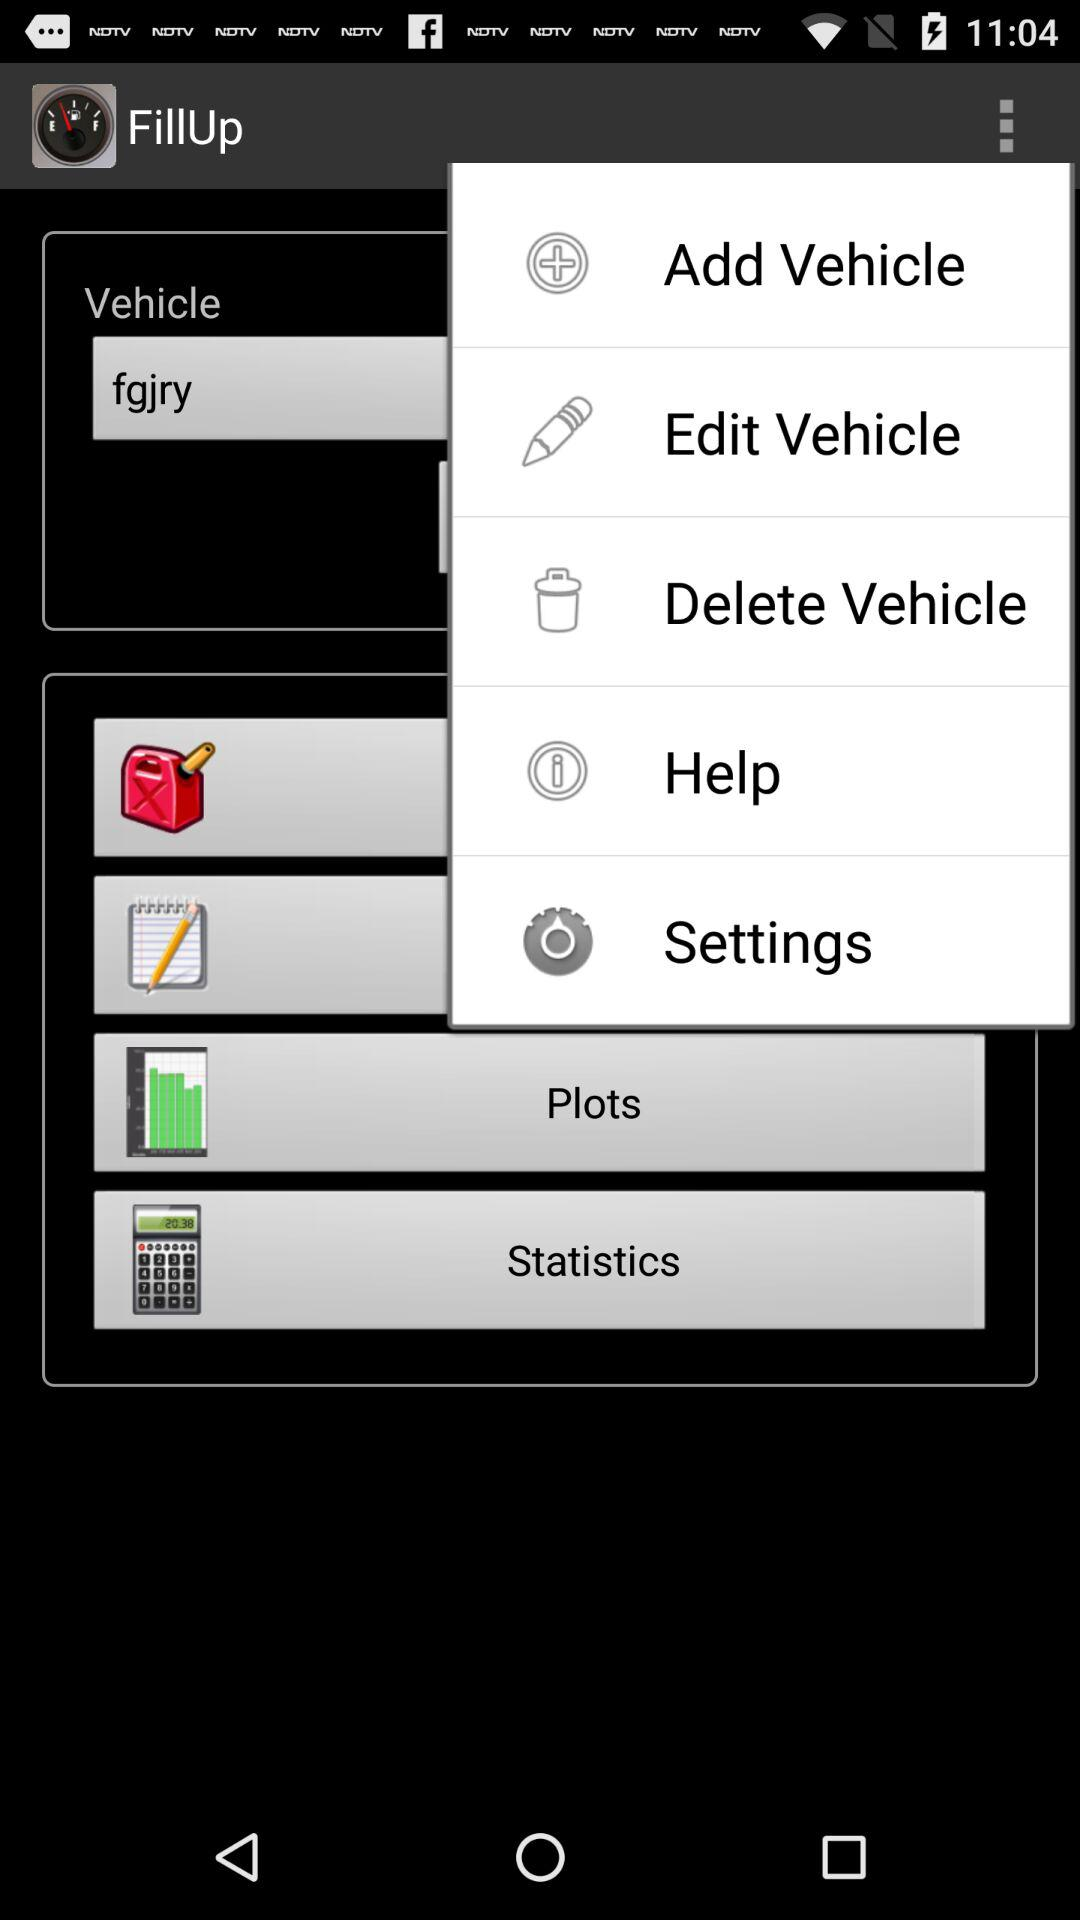What is the application name? The application name is "FillUp". 